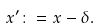<formula> <loc_0><loc_0><loc_500><loc_500>x ^ { \prime } \colon = x - \delta .</formula> 